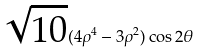Convert formula to latex. <formula><loc_0><loc_0><loc_500><loc_500>\sqrt { 1 0 } ( 4 \rho ^ { 4 } - 3 \rho ^ { 2 } ) \cos 2 \theta</formula> 